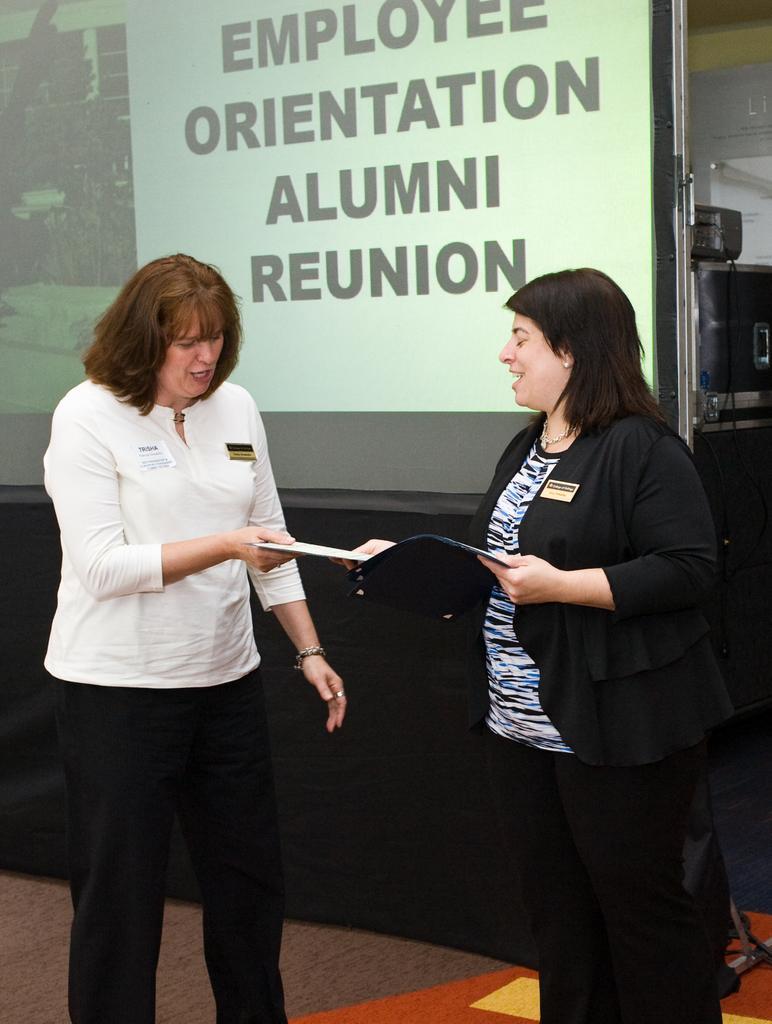How would you summarize this image in a sentence or two? In this image two ladies are standing. They are talking with each other. They are holding a book. In the background there is a screen. 